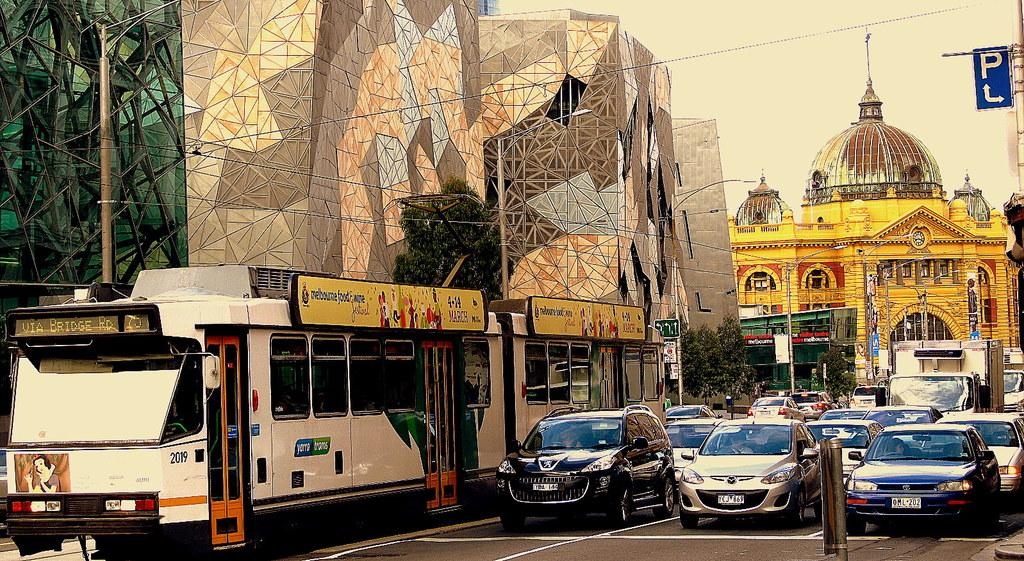<image>
Create a compact narrative representing the image presented. many cars and a sign with the letter P above the street 